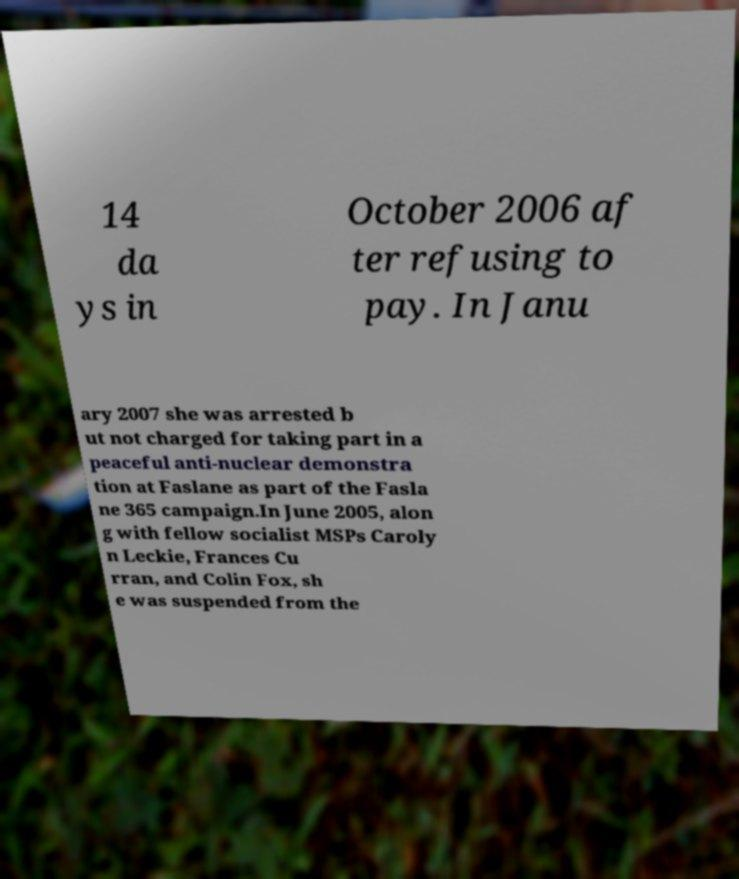What messages or text are displayed in this image? I need them in a readable, typed format. 14 da ys in October 2006 af ter refusing to pay. In Janu ary 2007 she was arrested b ut not charged for taking part in a peaceful anti-nuclear demonstra tion at Faslane as part of the Fasla ne 365 campaign.In June 2005, alon g with fellow socialist MSPs Caroly n Leckie, Frances Cu rran, and Colin Fox, sh e was suspended from the 